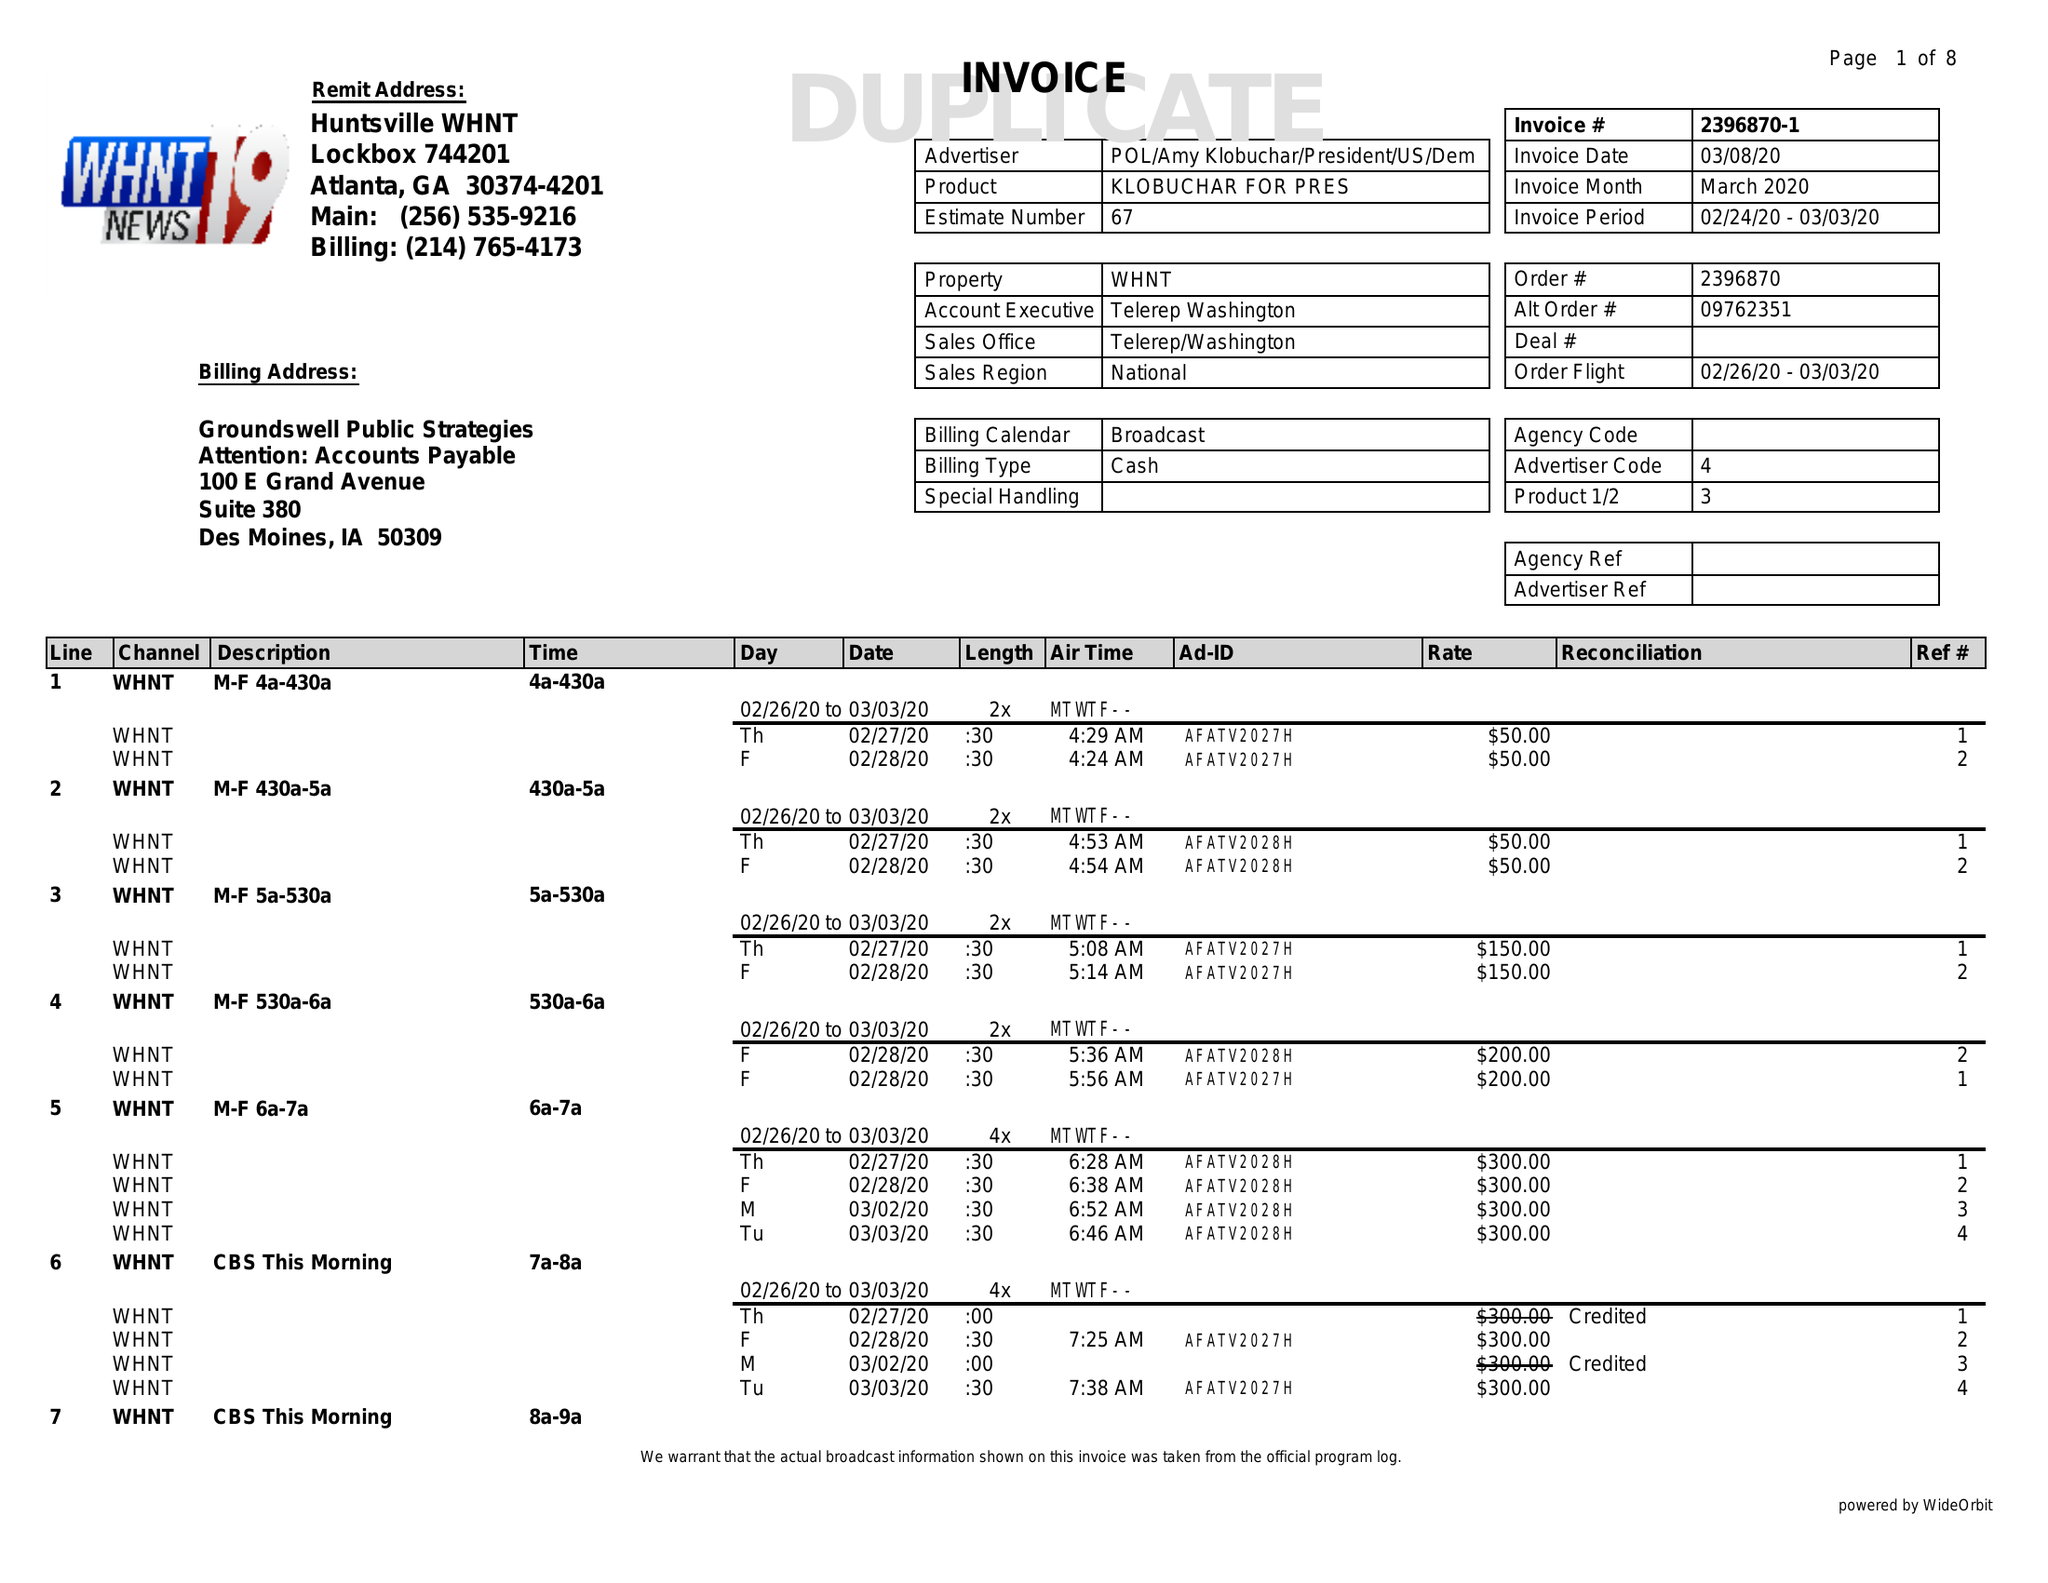What is the value for the flight_from?
Answer the question using a single word or phrase. 02/26/20 